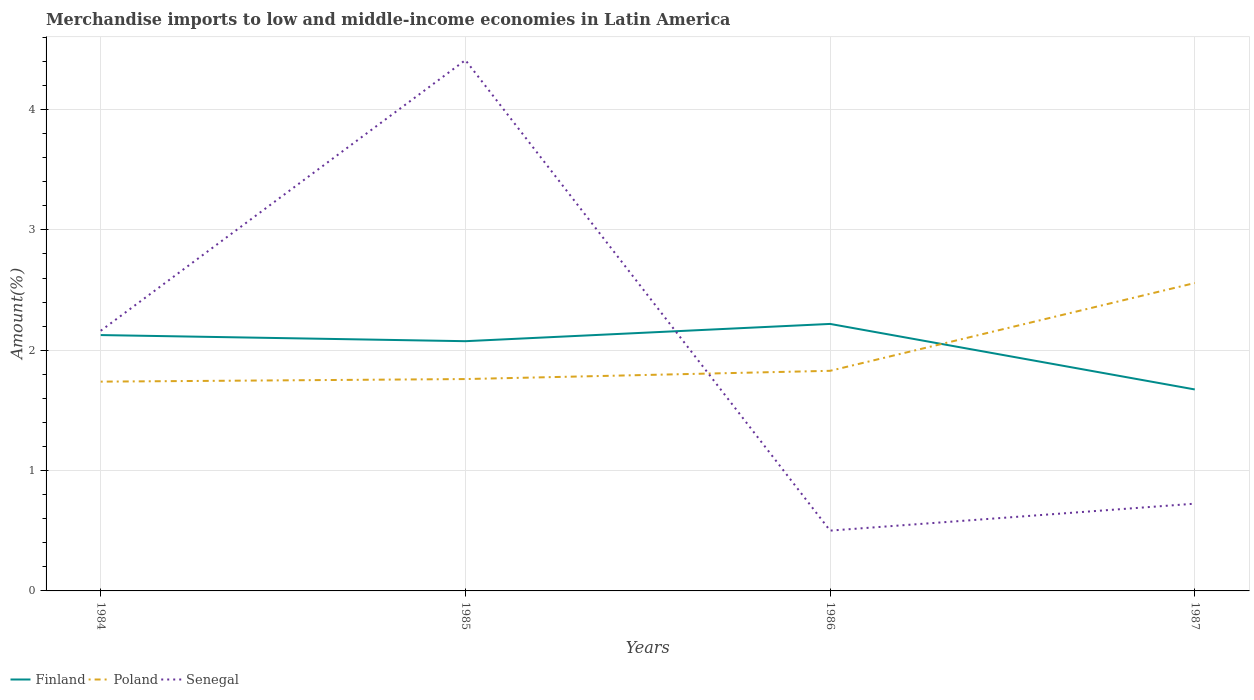Does the line corresponding to Finland intersect with the line corresponding to Poland?
Your answer should be compact. Yes. Is the number of lines equal to the number of legend labels?
Offer a very short reply. Yes. Across all years, what is the maximum percentage of amount earned from merchandise imports in Senegal?
Provide a short and direct response. 0.5. What is the total percentage of amount earned from merchandise imports in Senegal in the graph?
Offer a very short reply. 1.44. What is the difference between the highest and the second highest percentage of amount earned from merchandise imports in Senegal?
Offer a very short reply. 3.91. What is the difference between the highest and the lowest percentage of amount earned from merchandise imports in Poland?
Your answer should be compact. 1. Are the values on the major ticks of Y-axis written in scientific E-notation?
Give a very brief answer. No. Does the graph contain any zero values?
Offer a terse response. No. Does the graph contain grids?
Make the answer very short. Yes. Where does the legend appear in the graph?
Your answer should be compact. Bottom left. How many legend labels are there?
Keep it short and to the point. 3. How are the legend labels stacked?
Offer a very short reply. Horizontal. What is the title of the graph?
Offer a terse response. Merchandise imports to low and middle-income economies in Latin America. Does "Sub-Saharan Africa (developing only)" appear as one of the legend labels in the graph?
Give a very brief answer. No. What is the label or title of the X-axis?
Provide a short and direct response. Years. What is the label or title of the Y-axis?
Provide a short and direct response. Amount(%). What is the Amount(%) in Finland in 1984?
Ensure brevity in your answer.  2.13. What is the Amount(%) of Poland in 1984?
Your answer should be very brief. 1.74. What is the Amount(%) in Senegal in 1984?
Give a very brief answer. 2.16. What is the Amount(%) in Finland in 1985?
Offer a very short reply. 2.08. What is the Amount(%) of Poland in 1985?
Give a very brief answer. 1.76. What is the Amount(%) in Senegal in 1985?
Offer a terse response. 4.41. What is the Amount(%) of Finland in 1986?
Ensure brevity in your answer.  2.22. What is the Amount(%) of Poland in 1986?
Keep it short and to the point. 1.83. What is the Amount(%) in Senegal in 1986?
Offer a very short reply. 0.5. What is the Amount(%) of Finland in 1987?
Offer a terse response. 1.67. What is the Amount(%) in Poland in 1987?
Offer a very short reply. 2.56. What is the Amount(%) in Senegal in 1987?
Make the answer very short. 0.73. Across all years, what is the maximum Amount(%) in Finland?
Your answer should be compact. 2.22. Across all years, what is the maximum Amount(%) of Poland?
Give a very brief answer. 2.56. Across all years, what is the maximum Amount(%) of Senegal?
Your response must be concise. 4.41. Across all years, what is the minimum Amount(%) of Finland?
Provide a succinct answer. 1.67. Across all years, what is the minimum Amount(%) in Poland?
Offer a very short reply. 1.74. Across all years, what is the minimum Amount(%) in Senegal?
Keep it short and to the point. 0.5. What is the total Amount(%) of Finland in the graph?
Give a very brief answer. 8.09. What is the total Amount(%) of Poland in the graph?
Provide a short and direct response. 7.89. What is the total Amount(%) in Senegal in the graph?
Offer a very short reply. 7.8. What is the difference between the Amount(%) of Finland in 1984 and that in 1985?
Your answer should be compact. 0.05. What is the difference between the Amount(%) of Poland in 1984 and that in 1985?
Give a very brief answer. -0.02. What is the difference between the Amount(%) of Senegal in 1984 and that in 1985?
Offer a terse response. -2.25. What is the difference between the Amount(%) of Finland in 1984 and that in 1986?
Make the answer very short. -0.09. What is the difference between the Amount(%) of Poland in 1984 and that in 1986?
Offer a very short reply. -0.09. What is the difference between the Amount(%) in Senegal in 1984 and that in 1986?
Give a very brief answer. 1.66. What is the difference between the Amount(%) of Finland in 1984 and that in 1987?
Your answer should be compact. 0.45. What is the difference between the Amount(%) in Poland in 1984 and that in 1987?
Ensure brevity in your answer.  -0.82. What is the difference between the Amount(%) in Senegal in 1984 and that in 1987?
Offer a terse response. 1.44. What is the difference between the Amount(%) of Finland in 1985 and that in 1986?
Offer a terse response. -0.14. What is the difference between the Amount(%) in Poland in 1985 and that in 1986?
Offer a terse response. -0.07. What is the difference between the Amount(%) of Senegal in 1985 and that in 1986?
Your response must be concise. 3.91. What is the difference between the Amount(%) of Finland in 1985 and that in 1987?
Your response must be concise. 0.4. What is the difference between the Amount(%) of Poland in 1985 and that in 1987?
Make the answer very short. -0.8. What is the difference between the Amount(%) in Senegal in 1985 and that in 1987?
Your answer should be very brief. 3.69. What is the difference between the Amount(%) of Finland in 1986 and that in 1987?
Provide a succinct answer. 0.54. What is the difference between the Amount(%) in Poland in 1986 and that in 1987?
Your answer should be compact. -0.73. What is the difference between the Amount(%) in Senegal in 1986 and that in 1987?
Make the answer very short. -0.22. What is the difference between the Amount(%) of Finland in 1984 and the Amount(%) of Poland in 1985?
Your answer should be compact. 0.37. What is the difference between the Amount(%) in Finland in 1984 and the Amount(%) in Senegal in 1985?
Make the answer very short. -2.28. What is the difference between the Amount(%) of Poland in 1984 and the Amount(%) of Senegal in 1985?
Your answer should be very brief. -2.67. What is the difference between the Amount(%) of Finland in 1984 and the Amount(%) of Poland in 1986?
Offer a very short reply. 0.3. What is the difference between the Amount(%) in Finland in 1984 and the Amount(%) in Senegal in 1986?
Give a very brief answer. 1.62. What is the difference between the Amount(%) of Poland in 1984 and the Amount(%) of Senegal in 1986?
Your answer should be compact. 1.24. What is the difference between the Amount(%) of Finland in 1984 and the Amount(%) of Poland in 1987?
Provide a succinct answer. -0.43. What is the difference between the Amount(%) in Finland in 1984 and the Amount(%) in Senegal in 1987?
Offer a terse response. 1.4. What is the difference between the Amount(%) in Poland in 1984 and the Amount(%) in Senegal in 1987?
Your answer should be compact. 1.01. What is the difference between the Amount(%) in Finland in 1985 and the Amount(%) in Poland in 1986?
Offer a terse response. 0.25. What is the difference between the Amount(%) in Finland in 1985 and the Amount(%) in Senegal in 1986?
Offer a very short reply. 1.57. What is the difference between the Amount(%) of Poland in 1985 and the Amount(%) of Senegal in 1986?
Make the answer very short. 1.26. What is the difference between the Amount(%) in Finland in 1985 and the Amount(%) in Poland in 1987?
Provide a short and direct response. -0.48. What is the difference between the Amount(%) in Finland in 1985 and the Amount(%) in Senegal in 1987?
Provide a short and direct response. 1.35. What is the difference between the Amount(%) in Poland in 1985 and the Amount(%) in Senegal in 1987?
Make the answer very short. 1.04. What is the difference between the Amount(%) in Finland in 1986 and the Amount(%) in Poland in 1987?
Offer a very short reply. -0.34. What is the difference between the Amount(%) of Finland in 1986 and the Amount(%) of Senegal in 1987?
Your answer should be very brief. 1.49. What is the difference between the Amount(%) of Poland in 1986 and the Amount(%) of Senegal in 1987?
Provide a succinct answer. 1.1. What is the average Amount(%) of Finland per year?
Your response must be concise. 2.02. What is the average Amount(%) of Poland per year?
Offer a terse response. 1.97. What is the average Amount(%) of Senegal per year?
Ensure brevity in your answer.  1.95. In the year 1984, what is the difference between the Amount(%) of Finland and Amount(%) of Poland?
Provide a succinct answer. 0.39. In the year 1984, what is the difference between the Amount(%) of Finland and Amount(%) of Senegal?
Make the answer very short. -0.04. In the year 1984, what is the difference between the Amount(%) in Poland and Amount(%) in Senegal?
Provide a short and direct response. -0.42. In the year 1985, what is the difference between the Amount(%) of Finland and Amount(%) of Poland?
Your response must be concise. 0.31. In the year 1985, what is the difference between the Amount(%) in Finland and Amount(%) in Senegal?
Your response must be concise. -2.34. In the year 1985, what is the difference between the Amount(%) of Poland and Amount(%) of Senegal?
Provide a short and direct response. -2.65. In the year 1986, what is the difference between the Amount(%) of Finland and Amount(%) of Poland?
Ensure brevity in your answer.  0.39. In the year 1986, what is the difference between the Amount(%) in Finland and Amount(%) in Senegal?
Keep it short and to the point. 1.72. In the year 1986, what is the difference between the Amount(%) of Poland and Amount(%) of Senegal?
Keep it short and to the point. 1.33. In the year 1987, what is the difference between the Amount(%) in Finland and Amount(%) in Poland?
Provide a short and direct response. -0.88. In the year 1987, what is the difference between the Amount(%) in Finland and Amount(%) in Senegal?
Your answer should be very brief. 0.95. In the year 1987, what is the difference between the Amount(%) of Poland and Amount(%) of Senegal?
Your response must be concise. 1.83. What is the ratio of the Amount(%) of Finland in 1984 to that in 1985?
Offer a very short reply. 1.02. What is the ratio of the Amount(%) in Poland in 1984 to that in 1985?
Your answer should be compact. 0.99. What is the ratio of the Amount(%) of Senegal in 1984 to that in 1985?
Offer a terse response. 0.49. What is the ratio of the Amount(%) of Finland in 1984 to that in 1986?
Give a very brief answer. 0.96. What is the ratio of the Amount(%) in Poland in 1984 to that in 1986?
Give a very brief answer. 0.95. What is the ratio of the Amount(%) in Senegal in 1984 to that in 1986?
Make the answer very short. 4.31. What is the ratio of the Amount(%) of Finland in 1984 to that in 1987?
Ensure brevity in your answer.  1.27. What is the ratio of the Amount(%) of Poland in 1984 to that in 1987?
Your answer should be compact. 0.68. What is the ratio of the Amount(%) of Senegal in 1984 to that in 1987?
Make the answer very short. 2.98. What is the ratio of the Amount(%) in Finland in 1985 to that in 1986?
Your answer should be very brief. 0.94. What is the ratio of the Amount(%) in Poland in 1985 to that in 1986?
Offer a very short reply. 0.96. What is the ratio of the Amount(%) in Senegal in 1985 to that in 1986?
Offer a terse response. 8.8. What is the ratio of the Amount(%) of Finland in 1985 to that in 1987?
Your answer should be compact. 1.24. What is the ratio of the Amount(%) of Poland in 1985 to that in 1987?
Offer a terse response. 0.69. What is the ratio of the Amount(%) in Senegal in 1985 to that in 1987?
Your response must be concise. 6.08. What is the ratio of the Amount(%) of Finland in 1986 to that in 1987?
Ensure brevity in your answer.  1.33. What is the ratio of the Amount(%) of Poland in 1986 to that in 1987?
Offer a very short reply. 0.71. What is the ratio of the Amount(%) in Senegal in 1986 to that in 1987?
Provide a succinct answer. 0.69. What is the difference between the highest and the second highest Amount(%) in Finland?
Provide a succinct answer. 0.09. What is the difference between the highest and the second highest Amount(%) of Poland?
Ensure brevity in your answer.  0.73. What is the difference between the highest and the second highest Amount(%) of Senegal?
Offer a terse response. 2.25. What is the difference between the highest and the lowest Amount(%) in Finland?
Offer a very short reply. 0.54. What is the difference between the highest and the lowest Amount(%) in Poland?
Your answer should be very brief. 0.82. What is the difference between the highest and the lowest Amount(%) of Senegal?
Ensure brevity in your answer.  3.91. 